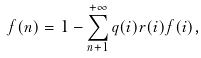Convert formula to latex. <formula><loc_0><loc_0><loc_500><loc_500>f ( n ) = 1 - \sum _ { n + { 1 } } ^ { + \infty } q ( i ) r ( i ) f ( i ) ,</formula> 